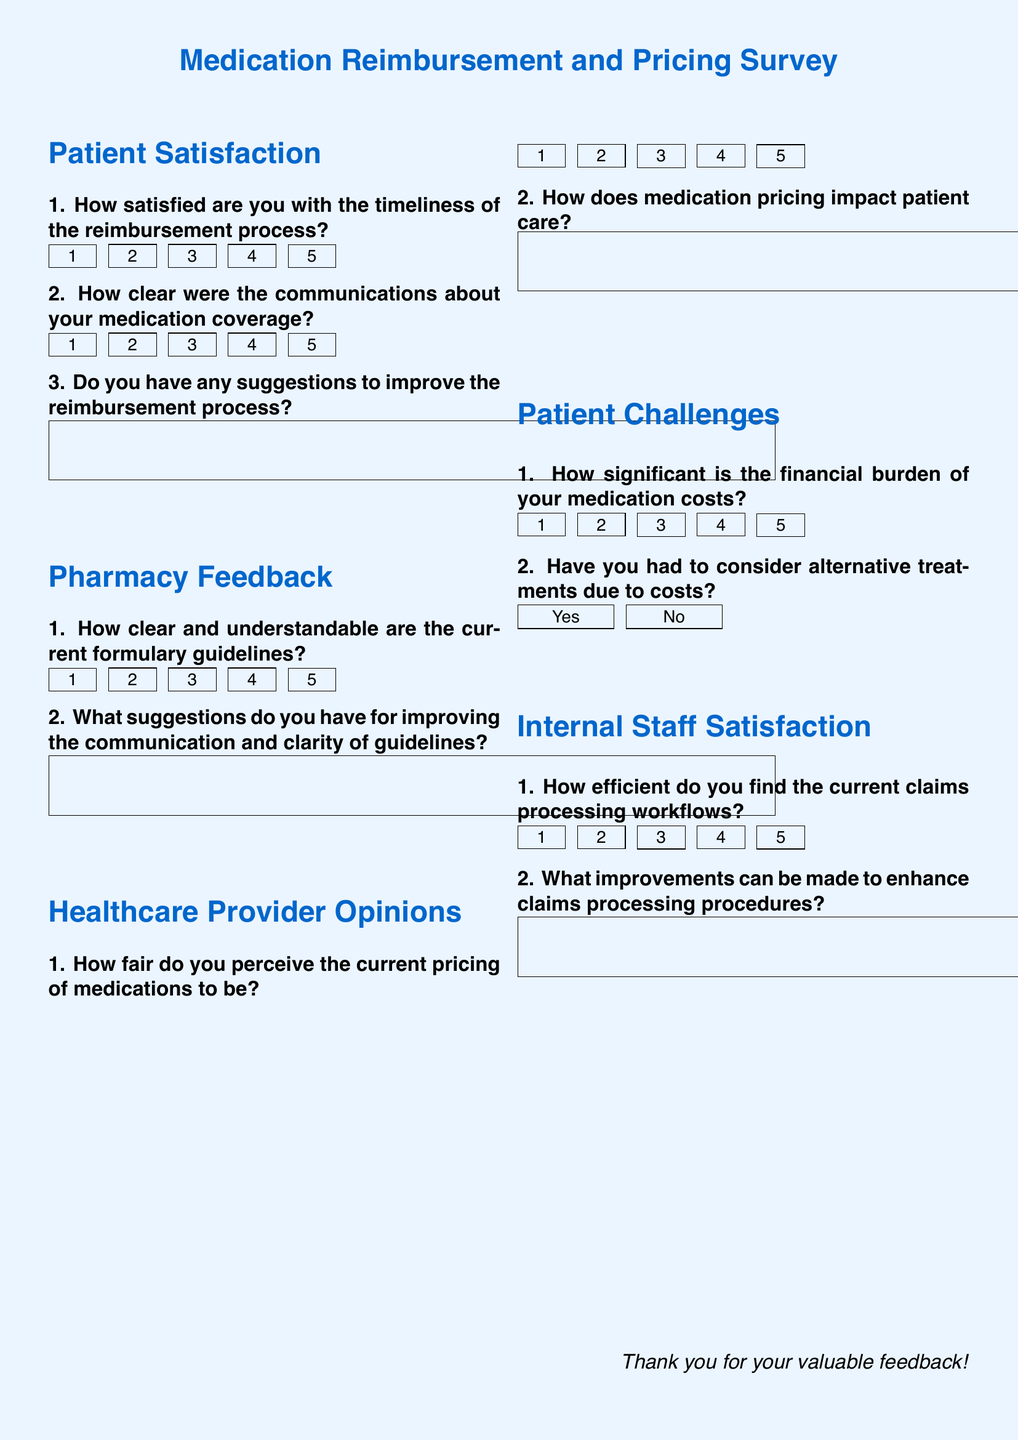What is the title of the survey? The title of the survey is prominently displayed at the top of the document, which reflects its focus on medication reimbursement and pricing.
Answer: Medication Reimbursement and Pricing Survey How many sections are included in the survey? The document contains five distinct sections, each targeting different stakeholder perspectives on medication-related issues.
Answer: Five What question asks about the clarity of formulary guidelines? This question is specifically related to pharmacy feedback and assesses how interpretable the formulary guidelines are for pharmacists.
Answer: 1. How clear and understandable are the current formulary guidelines? What is the scale used for patient satisfaction regarding reimbursement timeliness? The scale for measuring satisfaction is a five-point numerical scale, ranging from 1 to 5, where respondents can rate their satisfaction level.
Answer: 1 to 5 What type of feedback is solicited from healthcare providers? The survey seeks to gather opinions from healthcare providers regarding fairness in medication pricing and its impact on patient care.
Answer: Opinions on medication pricing What is the focus of the challenges faced by patients section? This section focuses on the financial burdens patients experience with their medication costs and any alternative treatments they might consider due to those costs.
Answer: Financial burden of medications What does the document ask internal staff to evaluate? The internal staff is asked to evaluate the efficiency of current claims processing workflows and suggest improvements.
Answer: Claims processing workflows What suggestion does the document encourage pharmacists to provide? The document encourages pharmacists to offer suggestions for enhancing the clarity and communication of formulary guidelines.
Answer: Suggestions for improving the communication and clarity of guidelines 